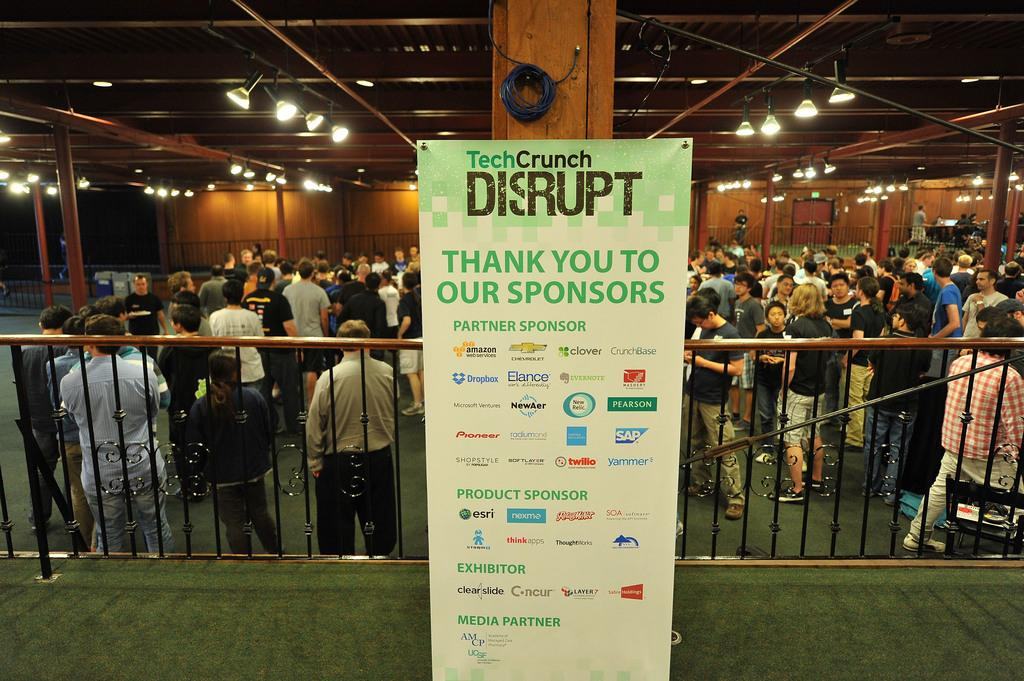How many people are in the image? There is a group of people in the image, but the exact number is not specified. Where are the people standing in the image? The people are standing under a big hall in the image. What can be seen in the image that provides illumination? A few lights are glowing in the image. What object is placed in the center of the image? There is an information object placed in the center of the image. Reasoning: Let' Let's think step by step in order to produce the conversation. We start by acknowledging the presence of a group of people in the image and their location under a big hall. Then, we mention the lights that provide illumination and the information object placed in the center of the image. We avoid asking questions that cannot be answered definitively and ensure that the language is simple and clear. Absurd Question/Answer: Can you tell me how many representatives are present in the image? There is no mention of representatives in the image; it features a group of people standing under a big hall. Is there an airplane visible in the image? No, there is no airplane present in the image. Can you tell me how many coils are present in the image? There is no mention of coils in the image; it features a group of people standing under a big hall, a few lights glowing, and an information object placed in the center. 